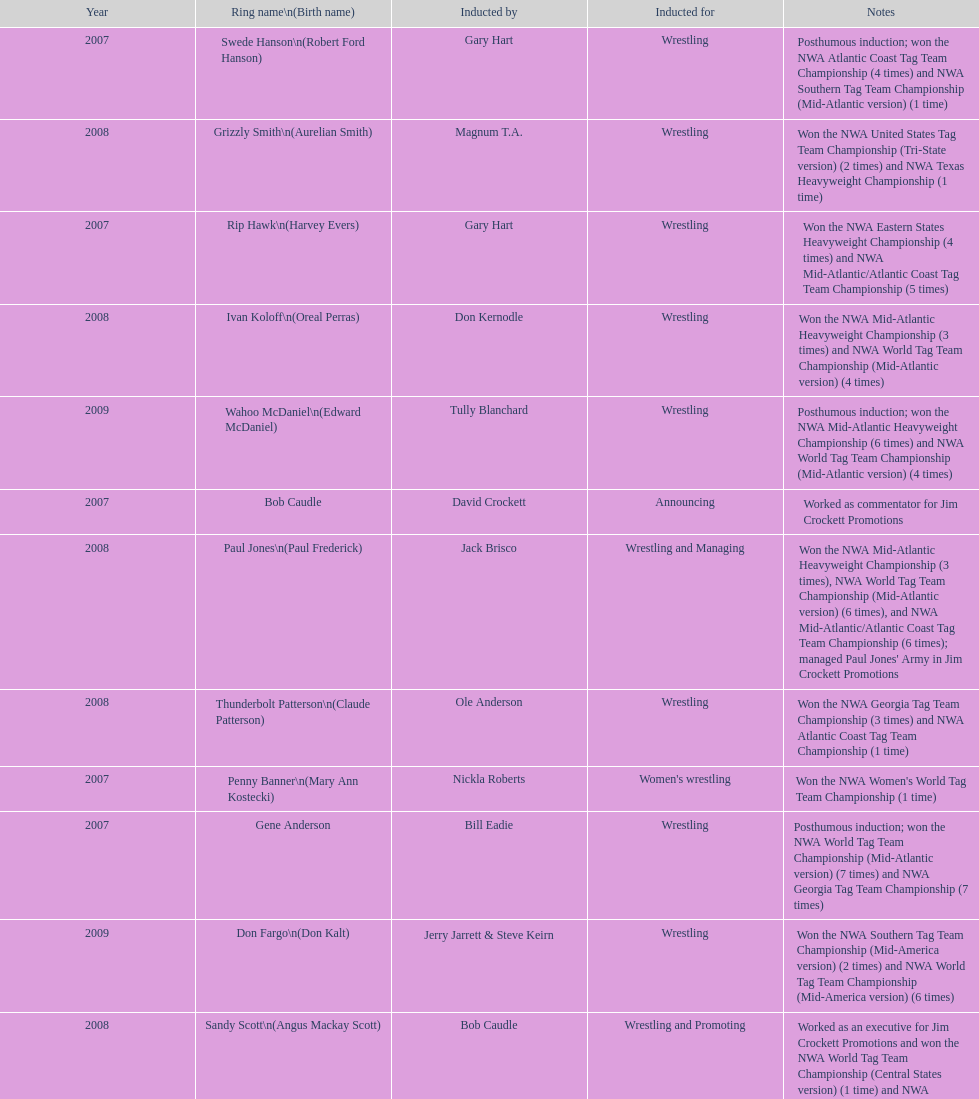Who's real name is dale hey, grizzly smith or buddy roberts? Buddy Roberts. 